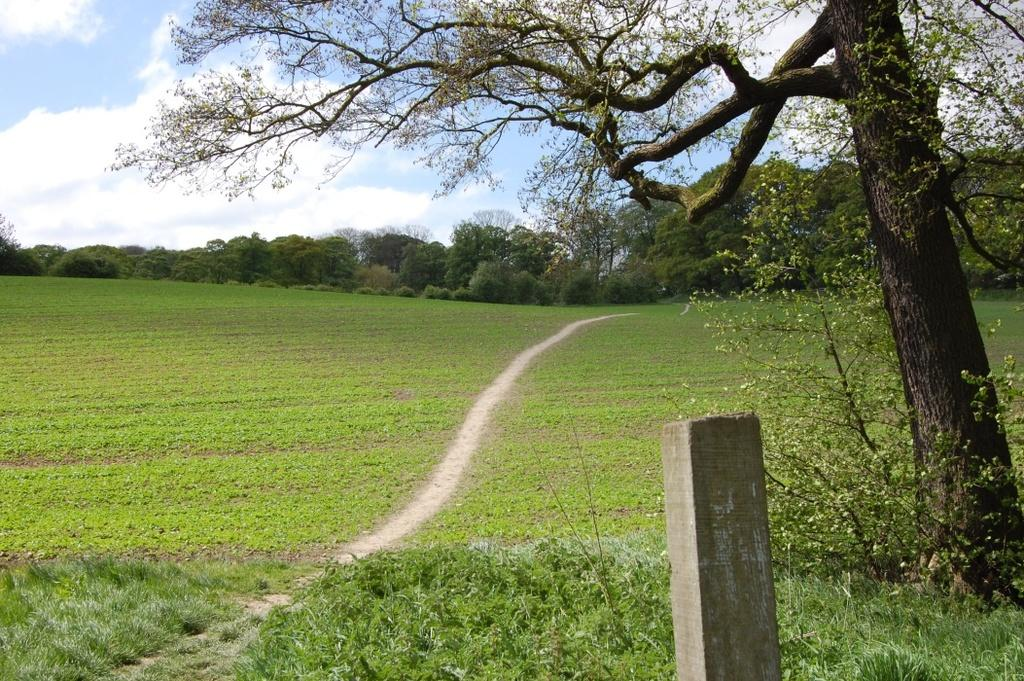What type of vegetation can be seen in the image? There is grass in the image. What other natural elements are present in the image? There is a tree in the image. Can you describe the wooden object in the image? There is a wooden object in the image. What can be seen in the background of the image? There are trees visible in the background of the image, and the sky is also visible. What is the condition of the sky in the image? Clouds are present in the sky in the image. Reasoning: Let' Let's think step by step in order to produce the conversation. We start by identifying the main natural elements in the image, which are the grass and the tree. Then, we mention the wooden object, which is a separate element in the image. Next, we describe the background, which includes trees and the sky. Finally, we focus on the sky's condition, which is cloudy. Absurd Question/Answer: What type of key is used to unlock the growth of the tree in the image? There is no key present in the image, and the growth of the tree is a natural process that does not require a key. 